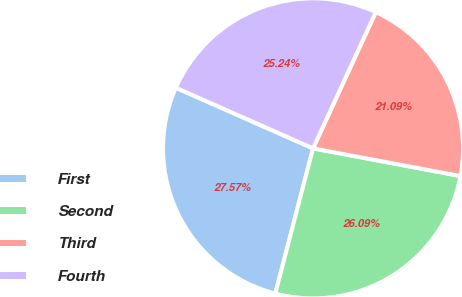<chart> <loc_0><loc_0><loc_500><loc_500><pie_chart><fcel>First<fcel>Second<fcel>Third<fcel>Fourth<nl><fcel>27.57%<fcel>26.09%<fcel>21.09%<fcel>25.24%<nl></chart> 